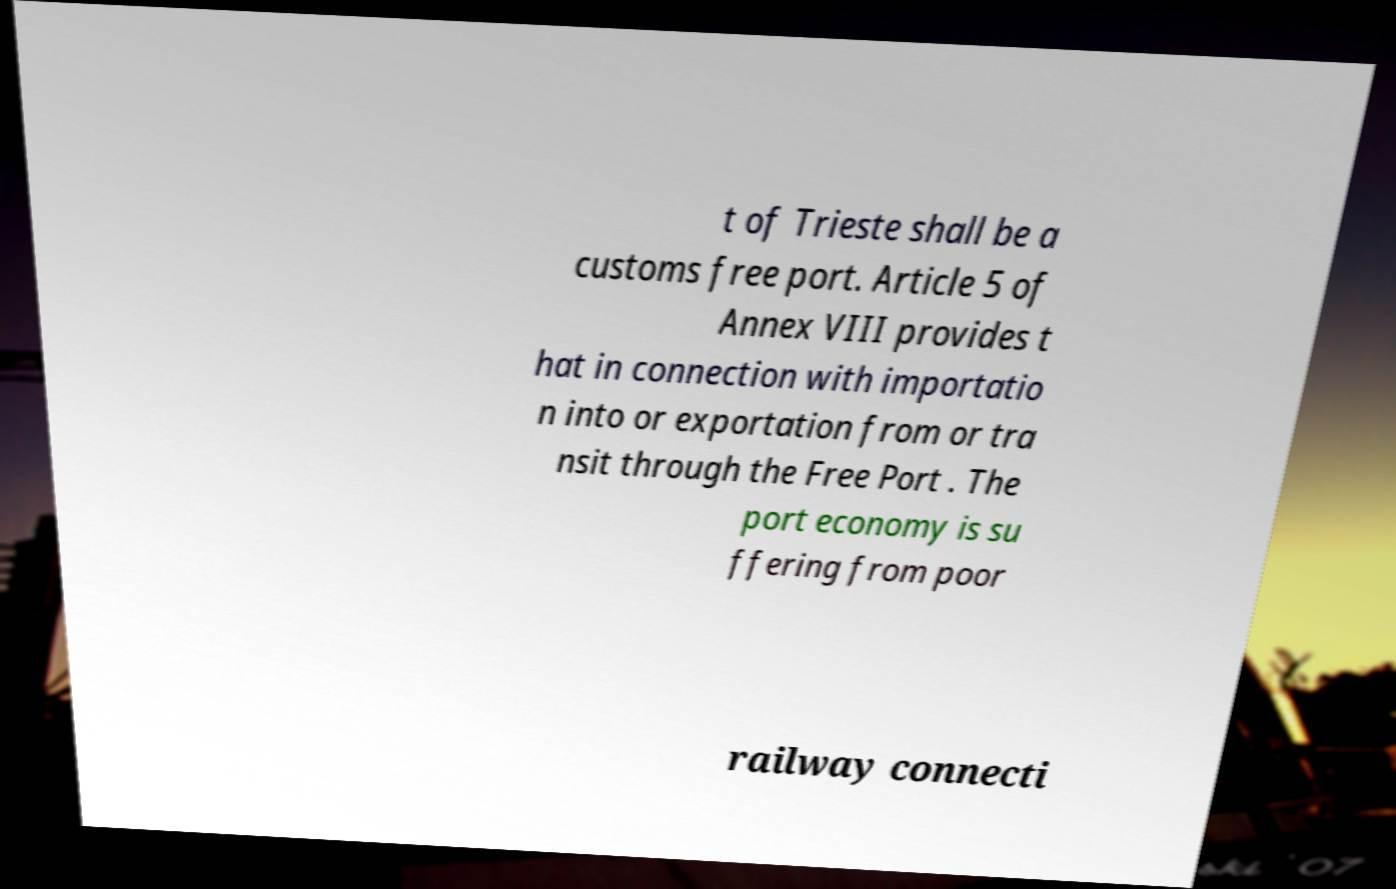For documentation purposes, I need the text within this image transcribed. Could you provide that? t of Trieste shall be a customs free port. Article 5 of Annex VIII provides t hat in connection with importatio n into or exportation from or tra nsit through the Free Port . The port economy is su ffering from poor railway connecti 